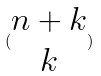<formula> <loc_0><loc_0><loc_500><loc_500>( \begin{matrix} n + k \\ k \end{matrix} )</formula> 